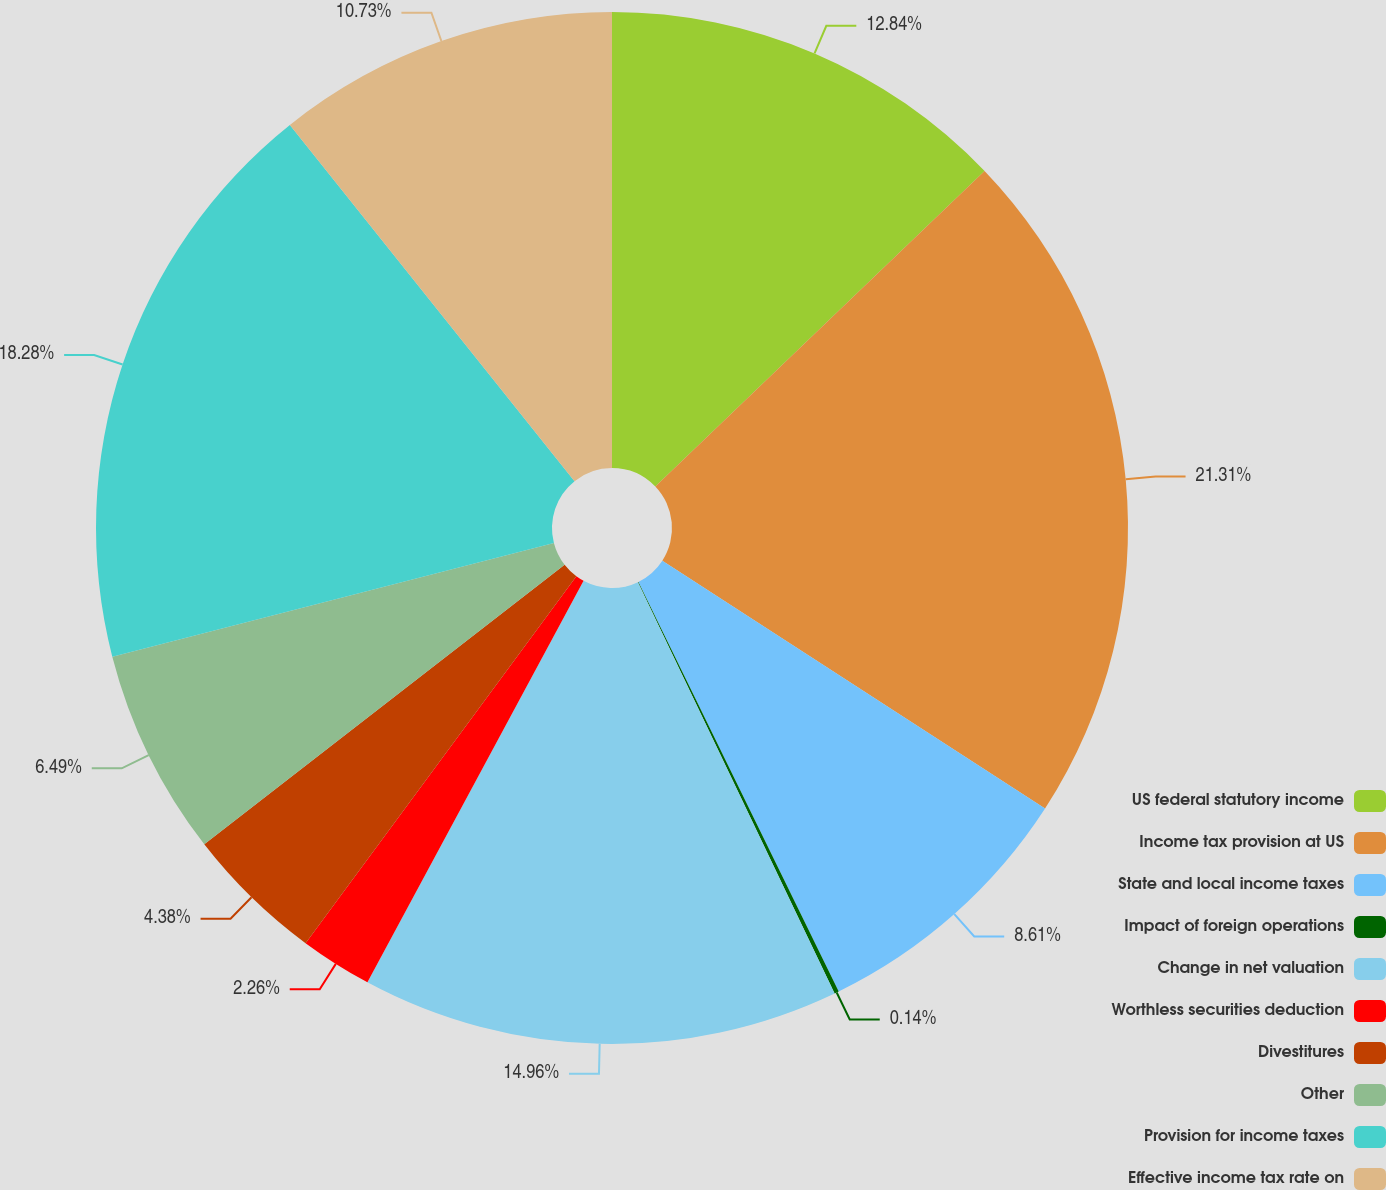Convert chart to OTSL. <chart><loc_0><loc_0><loc_500><loc_500><pie_chart><fcel>US federal statutory income<fcel>Income tax provision at US<fcel>State and local income taxes<fcel>Impact of foreign operations<fcel>Change in net valuation<fcel>Worthless securities deduction<fcel>Divestitures<fcel>Other<fcel>Provision for income taxes<fcel>Effective income tax rate on<nl><fcel>12.84%<fcel>21.31%<fcel>8.61%<fcel>0.14%<fcel>14.96%<fcel>2.26%<fcel>4.38%<fcel>6.49%<fcel>18.28%<fcel>10.73%<nl></chart> 